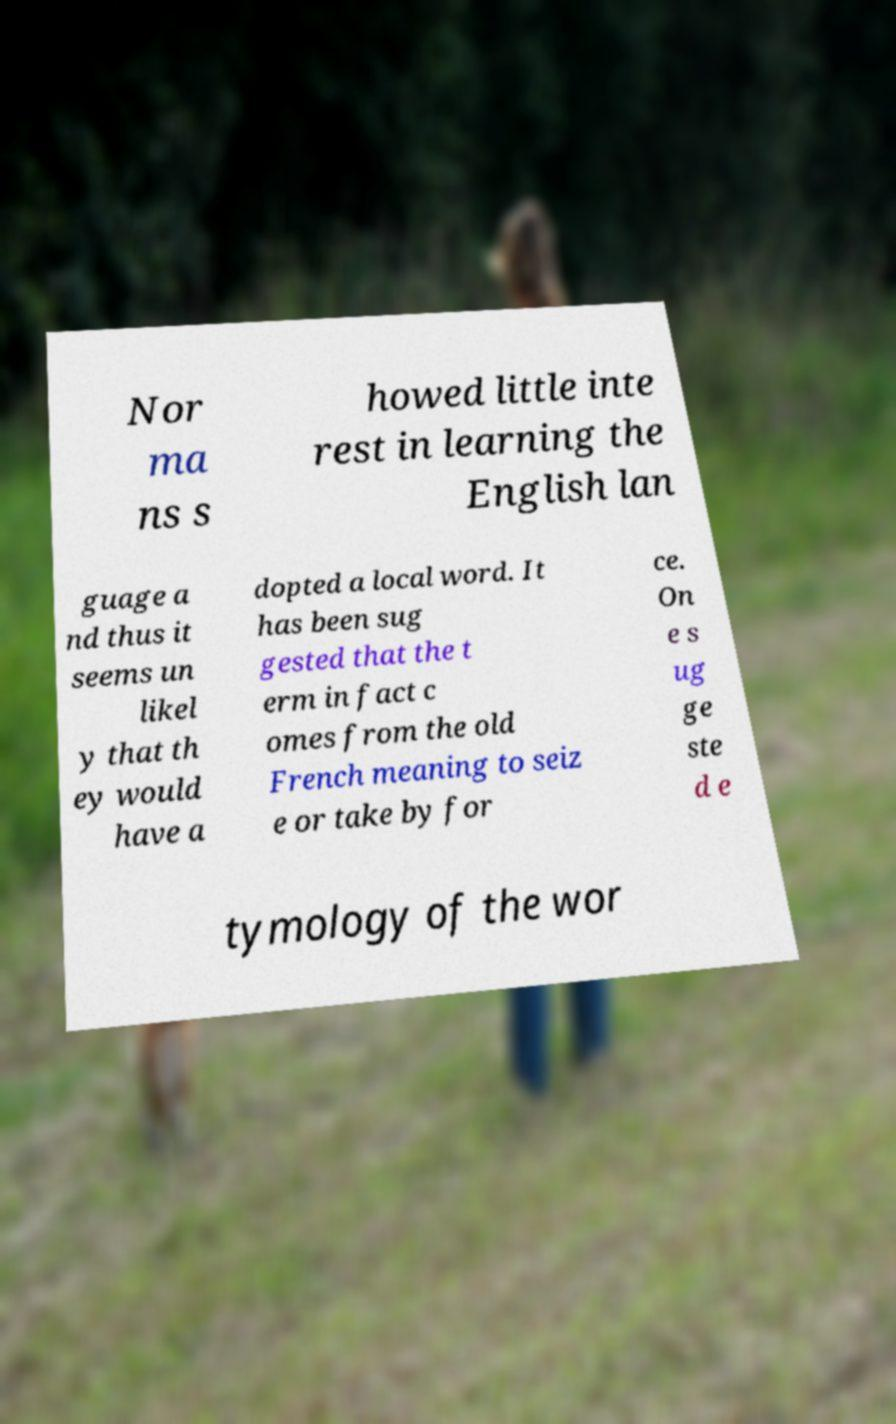Could you extract and type out the text from this image? Nor ma ns s howed little inte rest in learning the English lan guage a nd thus it seems un likel y that th ey would have a dopted a local word. It has been sug gested that the t erm in fact c omes from the old French meaning to seiz e or take by for ce. On e s ug ge ste d e tymology of the wor 